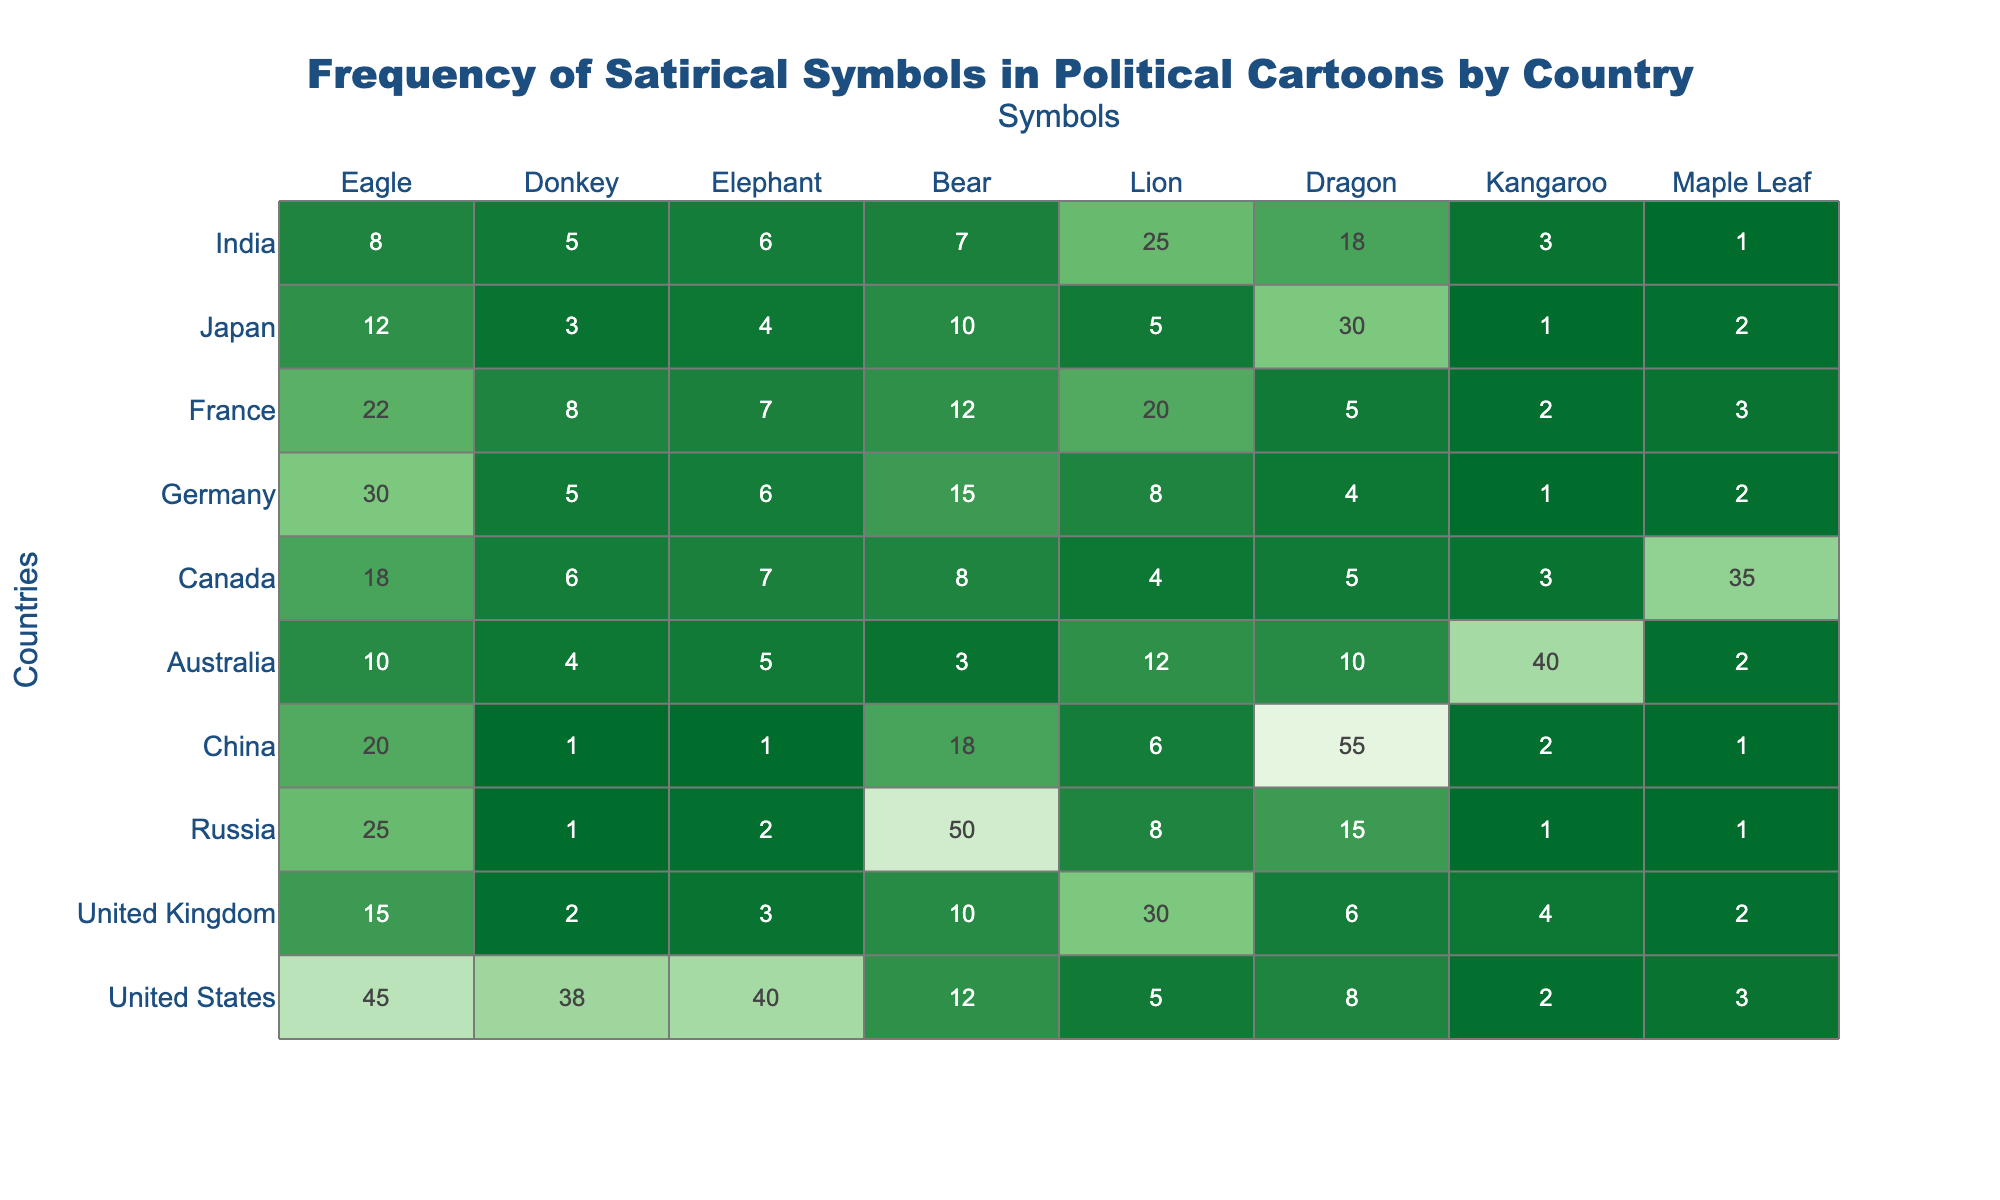What is the highest frequency symbol used in political cartoons in the United States? In the table, the frequencies for the United States are: Eagle (45), Donkey (38), Elephant (40), Bear (12), Lion (5), Dragon (8), Kangaroo (2), and Maple Leaf (3). The highest frequency is for the Eagle at 45.
Answer: Eagle Which country uses the Lion symbol the most? Looking at the Lion symbol's frequencies for each country, we have: United Kingdom (30), Australia (12), France (20), Japan (5), and others with lower values. The highest frequency for the Lion is 30 in the United Kingdom.
Answer: United Kingdom What is the total usage of the Bear symbol across all countries? To find this, we sum up the frequencies of the Bear symbol: 12 (US) + 10 (UK) + 50 (Russia) + 18 (China) + 3 (Australia) + 8 (Canada) + 15 (Germany) + 12 (France) + 10 (Japan) + 7 (India) =  105.
Answer: 105 Which country has the lowest usage of the Elephant symbol? The frequencies for the Elephant symbol are: 40 (US), 3 (UK), 2 (Russia), 1 (China), 5 (Australia), 7 (Canada), 6 (Germany), 7 (France), 4 (Japan), and 6 (India). The lowest frequency is 1, found in China.
Answer: China What is the average frequency of the Dragon symbol across all countries? The Dragon symbol frequencies are: 8 (US), 6 (UK), 15 (Russia), 1 (China), 10 (Australia), 5 (Canada), 4 (Germany), 5 (France), 30 (Japan), and 18 (India). Summing these gives 8 + 6 + 15 + 1 + 10 + 5 + 4 + 5 + 30 + 18 = 98. There are 10 countries, so the average is 98 / 10 = 9.8.
Answer: 9.8 Is the frequency of the Donkey symbol higher in France compared to Japan? The frequency of the Donkey symbol is 8 in France and 3 in Japan. Since 8 is greater than 3, the frequency is higher in France.
Answer: Yes What number of countries uses the Eagle symbol more than 20 times? The Eagle symbol has the following frequencies: 45 (US), 15 (UK), 25 (Russia), 20 (China), 10 (Australia), 18 (Canada), 30 (Germany), 22 (France), 12 (Japan), and 8 (India). Here, the countries with Eagle usage over 20 are the US, Russia, Canada, and France. That totals to 4 countries.
Answer: 4 Which symbol is the most frequently used in Australia and how does it compare to the second highest? In Australia, the frequency values are: Eagle (10), Donkey (4), Elephant (5), Bear (3), Lion (12), and Dragon (10). The Lion is the most used at 12, while the second highest is tied between Eagle and Dragon, both at 10. The Lion is higher than both the Eagle and Dragon.
Answer: Lion 